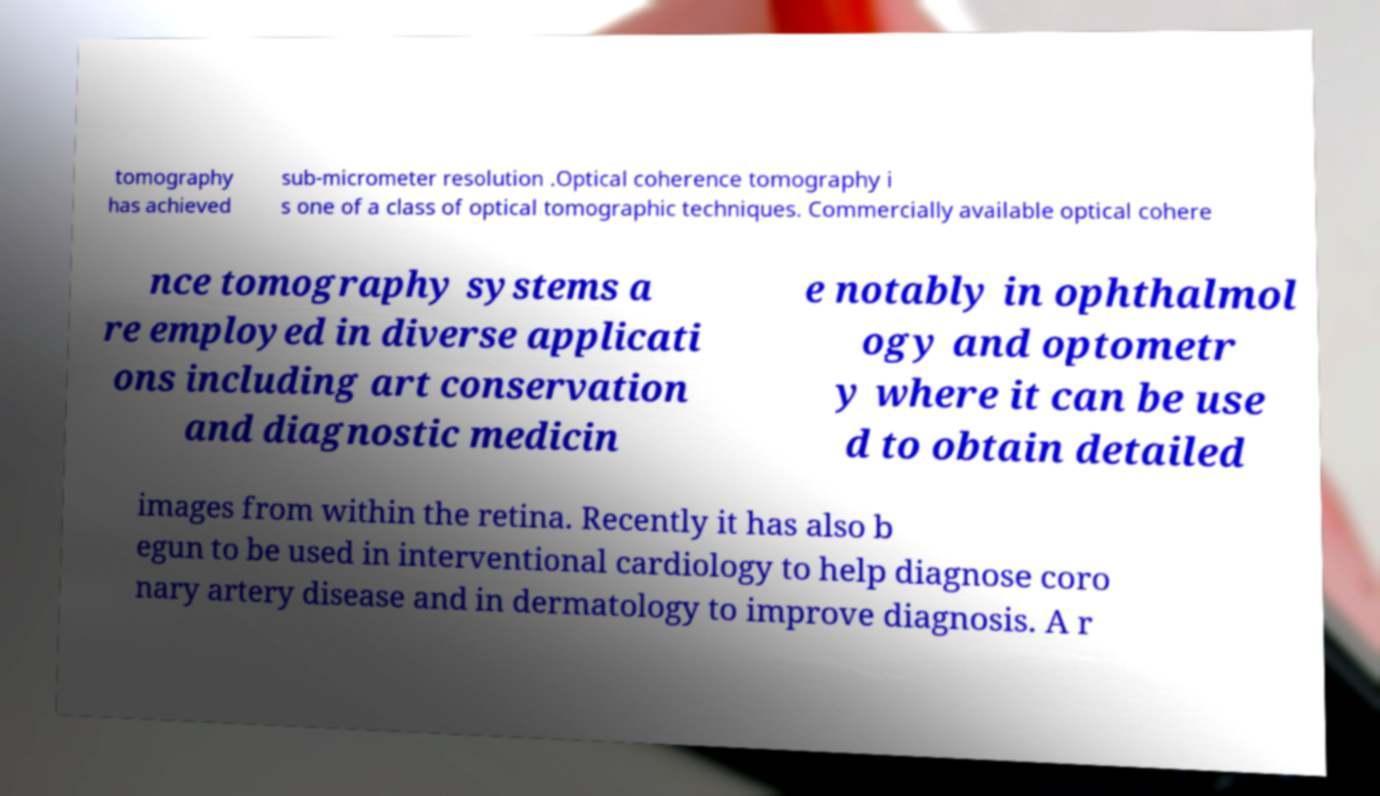There's text embedded in this image that I need extracted. Can you transcribe it verbatim? tomography has achieved sub-micrometer resolution .Optical coherence tomography i s one of a class of optical tomographic techniques. Commercially available optical cohere nce tomography systems a re employed in diverse applicati ons including art conservation and diagnostic medicin e notably in ophthalmol ogy and optometr y where it can be use d to obtain detailed images from within the retina. Recently it has also b egun to be used in interventional cardiology to help diagnose coro nary artery disease and in dermatology to improve diagnosis. A r 